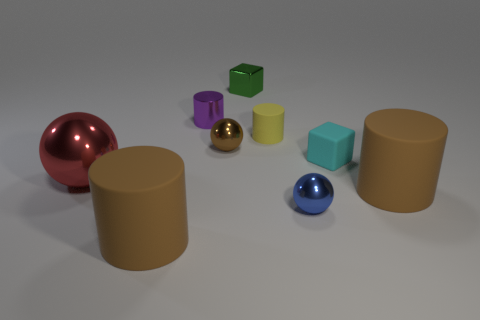There is a brown rubber cylinder to the right of the yellow matte thing; does it have the same size as the tiny purple thing? No, the brown rubber cylinder is significantly larger in size than the tiny purple object, which is a small sphere. 